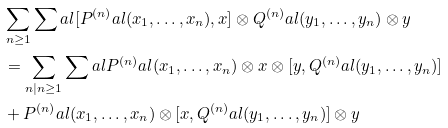Convert formula to latex. <formula><loc_0><loc_0><loc_500><loc_500>& \sum _ { n \geq 1 } \sum _ { \ } a l [ P ^ { ( n ) } _ { \ } a l ( x _ { 1 } , \dots , x _ { n } ) , x ] \otimes Q ^ { ( n ) } _ { \ } a l ( y _ { 1 } , \dots , y _ { n } ) \otimes y \\ & = \sum _ { n | n \geq 1 } \sum _ { \ } a l P ^ { ( n ) } _ { \ } a l ( x _ { 1 } , \dots , x _ { n } ) \otimes x \otimes [ y , Q ^ { ( n ) } _ { \ } a l ( y _ { 1 } , \dots , y _ { n } ) ] \\ & + P ^ { ( n ) } _ { \ } a l ( x _ { 1 } , \dots , x _ { n } ) \otimes [ x , Q ^ { ( n ) } _ { \ } a l ( y _ { 1 } , \dots , y _ { n } ) ] \otimes y</formula> 